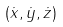<formula> <loc_0><loc_0><loc_500><loc_500>( \dot { x } , \dot { y } , \dot { z } )</formula> 